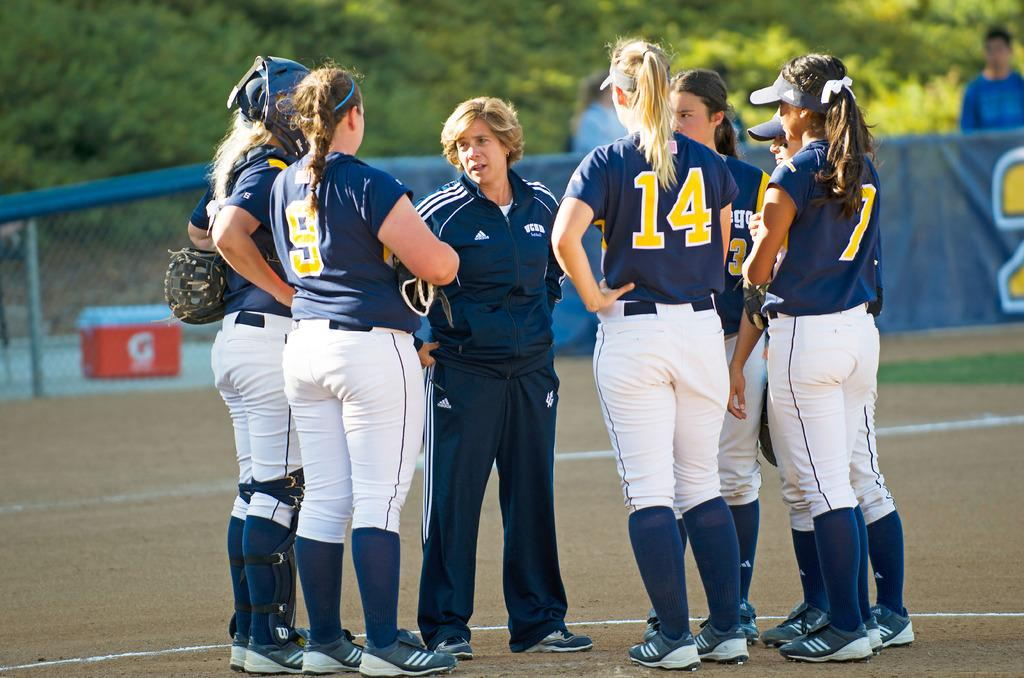<image>
Describe the image concisely. Players number 14 and 9 huddle with other players and a coach. 